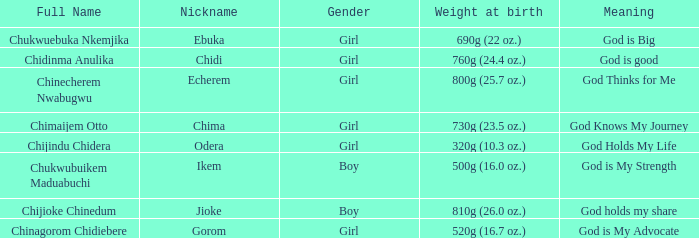Chukwubuikem Maduabuchi is what gender? Boy. 